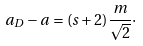<formula> <loc_0><loc_0><loc_500><loc_500>a _ { D } - a = ( s + 2 ) \frac { m } { \sqrt { 2 } } \cdot</formula> 